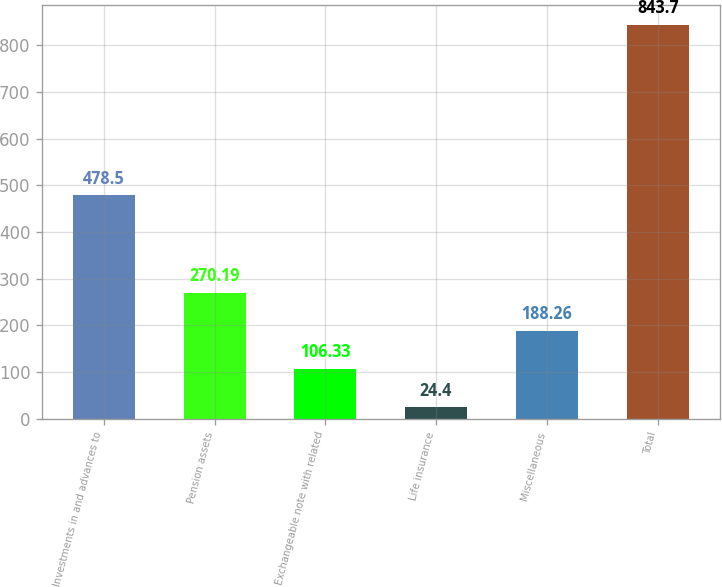Convert chart to OTSL. <chart><loc_0><loc_0><loc_500><loc_500><bar_chart><fcel>Investments in and advances to<fcel>Pension assets<fcel>Exchangeable note with related<fcel>Life insurance<fcel>Miscellaneous<fcel>Total<nl><fcel>478.5<fcel>270.19<fcel>106.33<fcel>24.4<fcel>188.26<fcel>843.7<nl></chart> 